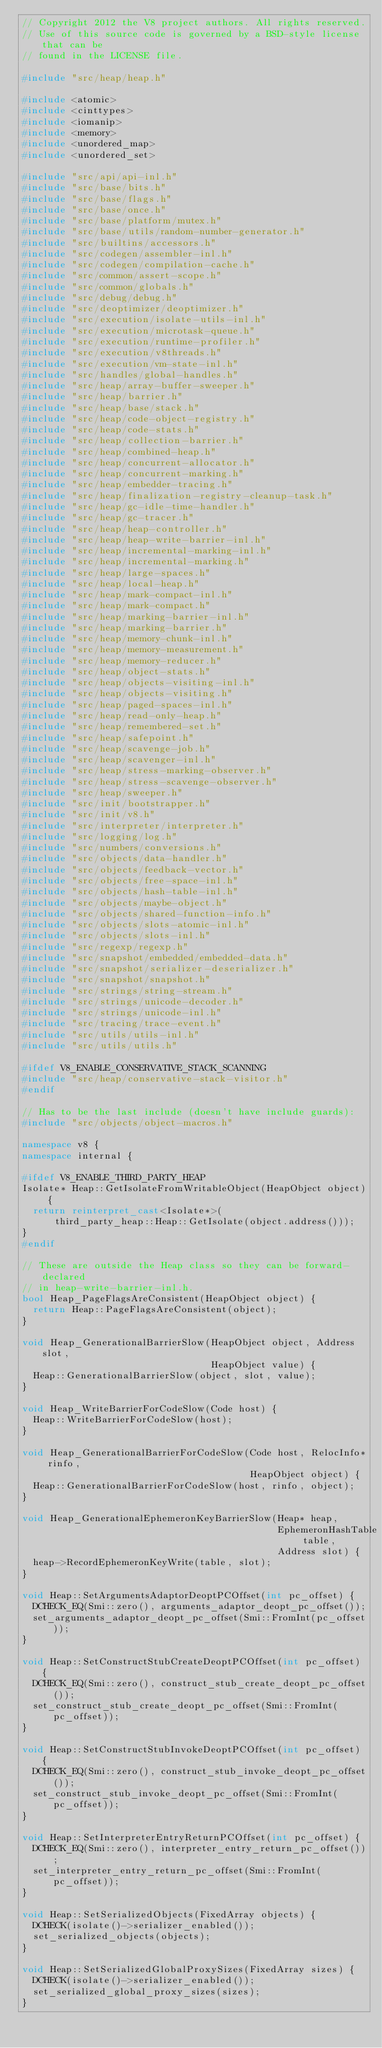Convert code to text. <code><loc_0><loc_0><loc_500><loc_500><_C++_>// Copyright 2012 the V8 project authors. All rights reserved.
// Use of this source code is governed by a BSD-style license that can be
// found in the LICENSE file.

#include "src/heap/heap.h"

#include <atomic>
#include <cinttypes>
#include <iomanip>
#include <memory>
#include <unordered_map>
#include <unordered_set>

#include "src/api/api-inl.h"
#include "src/base/bits.h"
#include "src/base/flags.h"
#include "src/base/once.h"
#include "src/base/platform/mutex.h"
#include "src/base/utils/random-number-generator.h"
#include "src/builtins/accessors.h"
#include "src/codegen/assembler-inl.h"
#include "src/codegen/compilation-cache.h"
#include "src/common/assert-scope.h"
#include "src/common/globals.h"
#include "src/debug/debug.h"
#include "src/deoptimizer/deoptimizer.h"
#include "src/execution/isolate-utils-inl.h"
#include "src/execution/microtask-queue.h"
#include "src/execution/runtime-profiler.h"
#include "src/execution/v8threads.h"
#include "src/execution/vm-state-inl.h"
#include "src/handles/global-handles.h"
#include "src/heap/array-buffer-sweeper.h"
#include "src/heap/barrier.h"
#include "src/heap/base/stack.h"
#include "src/heap/code-object-registry.h"
#include "src/heap/code-stats.h"
#include "src/heap/collection-barrier.h"
#include "src/heap/combined-heap.h"
#include "src/heap/concurrent-allocator.h"
#include "src/heap/concurrent-marking.h"
#include "src/heap/embedder-tracing.h"
#include "src/heap/finalization-registry-cleanup-task.h"
#include "src/heap/gc-idle-time-handler.h"
#include "src/heap/gc-tracer.h"
#include "src/heap/heap-controller.h"
#include "src/heap/heap-write-barrier-inl.h"
#include "src/heap/incremental-marking-inl.h"
#include "src/heap/incremental-marking.h"
#include "src/heap/large-spaces.h"
#include "src/heap/local-heap.h"
#include "src/heap/mark-compact-inl.h"
#include "src/heap/mark-compact.h"
#include "src/heap/marking-barrier-inl.h"
#include "src/heap/marking-barrier.h"
#include "src/heap/memory-chunk-inl.h"
#include "src/heap/memory-measurement.h"
#include "src/heap/memory-reducer.h"
#include "src/heap/object-stats.h"
#include "src/heap/objects-visiting-inl.h"
#include "src/heap/objects-visiting.h"
#include "src/heap/paged-spaces-inl.h"
#include "src/heap/read-only-heap.h"
#include "src/heap/remembered-set.h"
#include "src/heap/safepoint.h"
#include "src/heap/scavenge-job.h"
#include "src/heap/scavenger-inl.h"
#include "src/heap/stress-marking-observer.h"
#include "src/heap/stress-scavenge-observer.h"
#include "src/heap/sweeper.h"
#include "src/init/bootstrapper.h"
#include "src/init/v8.h"
#include "src/interpreter/interpreter.h"
#include "src/logging/log.h"
#include "src/numbers/conversions.h"
#include "src/objects/data-handler.h"
#include "src/objects/feedback-vector.h"
#include "src/objects/free-space-inl.h"
#include "src/objects/hash-table-inl.h"
#include "src/objects/maybe-object.h"
#include "src/objects/shared-function-info.h"
#include "src/objects/slots-atomic-inl.h"
#include "src/objects/slots-inl.h"
#include "src/regexp/regexp.h"
#include "src/snapshot/embedded/embedded-data.h"
#include "src/snapshot/serializer-deserializer.h"
#include "src/snapshot/snapshot.h"
#include "src/strings/string-stream.h"
#include "src/strings/unicode-decoder.h"
#include "src/strings/unicode-inl.h"
#include "src/tracing/trace-event.h"
#include "src/utils/utils-inl.h"
#include "src/utils/utils.h"

#ifdef V8_ENABLE_CONSERVATIVE_STACK_SCANNING
#include "src/heap/conservative-stack-visitor.h"
#endif

// Has to be the last include (doesn't have include guards):
#include "src/objects/object-macros.h"

namespace v8 {
namespace internal {

#ifdef V8_ENABLE_THIRD_PARTY_HEAP
Isolate* Heap::GetIsolateFromWritableObject(HeapObject object) {
  return reinterpret_cast<Isolate*>(
      third_party_heap::Heap::GetIsolate(object.address()));
}
#endif

// These are outside the Heap class so they can be forward-declared
// in heap-write-barrier-inl.h.
bool Heap_PageFlagsAreConsistent(HeapObject object) {
  return Heap::PageFlagsAreConsistent(object);
}

void Heap_GenerationalBarrierSlow(HeapObject object, Address slot,
                                  HeapObject value) {
  Heap::GenerationalBarrierSlow(object, slot, value);
}

void Heap_WriteBarrierForCodeSlow(Code host) {
  Heap::WriteBarrierForCodeSlow(host);
}

void Heap_GenerationalBarrierForCodeSlow(Code host, RelocInfo* rinfo,
                                         HeapObject object) {
  Heap::GenerationalBarrierForCodeSlow(host, rinfo, object);
}

void Heap_GenerationalEphemeronKeyBarrierSlow(Heap* heap,
                                              EphemeronHashTable table,
                                              Address slot) {
  heap->RecordEphemeronKeyWrite(table, slot);
}

void Heap::SetArgumentsAdaptorDeoptPCOffset(int pc_offset) {
  DCHECK_EQ(Smi::zero(), arguments_adaptor_deopt_pc_offset());
  set_arguments_adaptor_deopt_pc_offset(Smi::FromInt(pc_offset));
}

void Heap::SetConstructStubCreateDeoptPCOffset(int pc_offset) {
  DCHECK_EQ(Smi::zero(), construct_stub_create_deopt_pc_offset());
  set_construct_stub_create_deopt_pc_offset(Smi::FromInt(pc_offset));
}

void Heap::SetConstructStubInvokeDeoptPCOffset(int pc_offset) {
  DCHECK_EQ(Smi::zero(), construct_stub_invoke_deopt_pc_offset());
  set_construct_stub_invoke_deopt_pc_offset(Smi::FromInt(pc_offset));
}

void Heap::SetInterpreterEntryReturnPCOffset(int pc_offset) {
  DCHECK_EQ(Smi::zero(), interpreter_entry_return_pc_offset());
  set_interpreter_entry_return_pc_offset(Smi::FromInt(pc_offset));
}

void Heap::SetSerializedObjects(FixedArray objects) {
  DCHECK(isolate()->serializer_enabled());
  set_serialized_objects(objects);
}

void Heap::SetSerializedGlobalProxySizes(FixedArray sizes) {
  DCHECK(isolate()->serializer_enabled());
  set_serialized_global_proxy_sizes(sizes);
}
</code> 